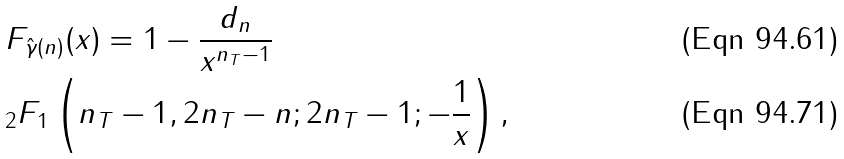<formula> <loc_0><loc_0><loc_500><loc_500>& F _ { \hat { \gamma } ( n ) } ( x ) = 1 - \frac { d _ { n } } { x ^ { n _ { T } - 1 } } \\ & _ { 2 } F _ { 1 } \left ( n _ { T } - 1 , 2 n _ { T } - n ; 2 n _ { T } - 1 ; - \frac { 1 } { x } \right ) ,</formula> 